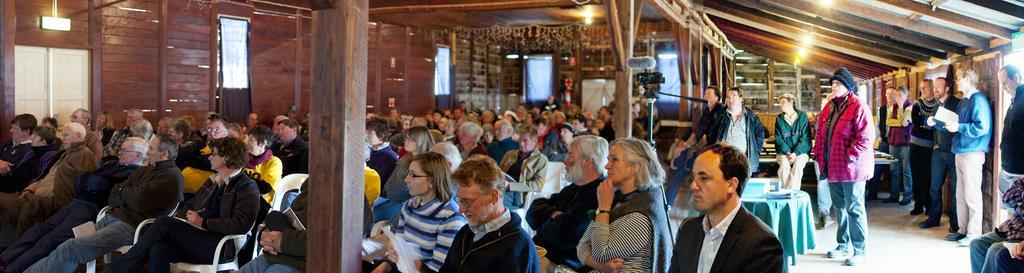Can you describe this image briefly? In a room there are many people sitting and some of them are standing on the right side, there is a camera in between the wooden poles and in the background there is a wooden wall, there are few windows to that wall. 